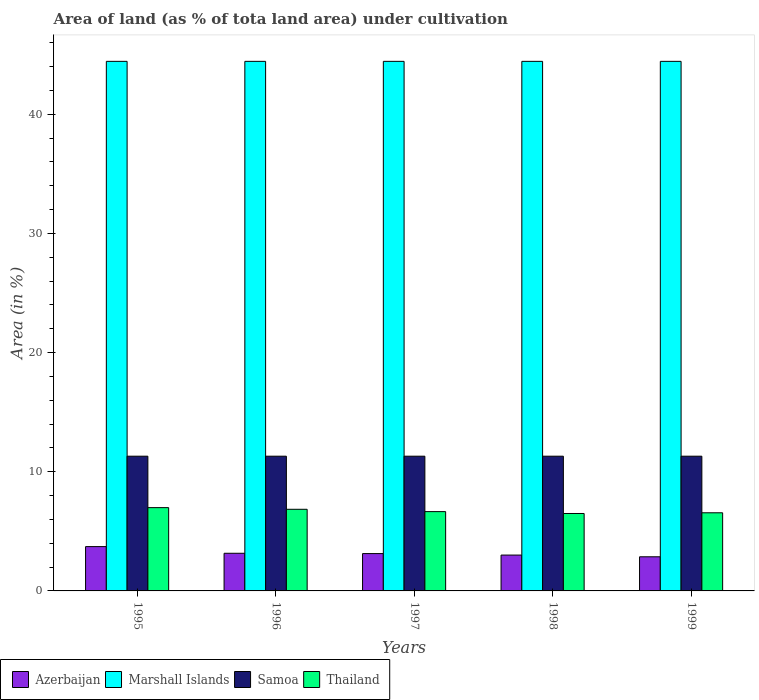How many different coloured bars are there?
Offer a terse response. 4. How many groups of bars are there?
Your answer should be very brief. 5. Are the number of bars on each tick of the X-axis equal?
Provide a succinct answer. Yes. How many bars are there on the 3rd tick from the left?
Your response must be concise. 4. What is the label of the 3rd group of bars from the left?
Your response must be concise. 1997. What is the percentage of land under cultivation in Azerbaijan in 1998?
Give a very brief answer. 3.01. Across all years, what is the maximum percentage of land under cultivation in Thailand?
Offer a very short reply. 6.99. Across all years, what is the minimum percentage of land under cultivation in Thailand?
Your response must be concise. 6.5. In which year was the percentage of land under cultivation in Thailand maximum?
Give a very brief answer. 1995. In which year was the percentage of land under cultivation in Azerbaijan minimum?
Keep it short and to the point. 1999. What is the total percentage of land under cultivation in Azerbaijan in the graph?
Your answer should be compact. 15.89. What is the difference between the percentage of land under cultivation in Thailand in 1996 and that in 1997?
Provide a short and direct response. 0.2. What is the difference between the percentage of land under cultivation in Marshall Islands in 1999 and the percentage of land under cultivation in Azerbaijan in 1995?
Offer a very short reply. 40.73. What is the average percentage of land under cultivation in Samoa per year?
Ensure brevity in your answer.  11.31. In the year 1995, what is the difference between the percentage of land under cultivation in Thailand and percentage of land under cultivation in Azerbaijan?
Your response must be concise. 3.27. In how many years, is the percentage of land under cultivation in Thailand greater than 40 %?
Provide a short and direct response. 0. Is the difference between the percentage of land under cultivation in Thailand in 1995 and 1996 greater than the difference between the percentage of land under cultivation in Azerbaijan in 1995 and 1996?
Your answer should be compact. No. In how many years, is the percentage of land under cultivation in Thailand greater than the average percentage of land under cultivation in Thailand taken over all years?
Your answer should be very brief. 2. What does the 1st bar from the left in 1996 represents?
Ensure brevity in your answer.  Azerbaijan. What does the 3rd bar from the right in 1995 represents?
Ensure brevity in your answer.  Marshall Islands. How many bars are there?
Make the answer very short. 20. How many years are there in the graph?
Provide a short and direct response. 5. What is the difference between two consecutive major ticks on the Y-axis?
Your response must be concise. 10. Does the graph contain grids?
Ensure brevity in your answer.  No. How are the legend labels stacked?
Your answer should be very brief. Horizontal. What is the title of the graph?
Give a very brief answer. Area of land (as % of tota land area) under cultivation. Does "Iran" appear as one of the legend labels in the graph?
Your answer should be very brief. No. What is the label or title of the Y-axis?
Make the answer very short. Area (in %). What is the Area (in %) of Azerbaijan in 1995?
Make the answer very short. 3.72. What is the Area (in %) in Marshall Islands in 1995?
Offer a very short reply. 44.44. What is the Area (in %) in Samoa in 1995?
Your response must be concise. 11.31. What is the Area (in %) in Thailand in 1995?
Give a very brief answer. 6.99. What is the Area (in %) in Azerbaijan in 1996?
Your answer should be very brief. 3.16. What is the Area (in %) of Marshall Islands in 1996?
Provide a short and direct response. 44.44. What is the Area (in %) of Samoa in 1996?
Offer a terse response. 11.31. What is the Area (in %) in Thailand in 1996?
Your answer should be compact. 6.85. What is the Area (in %) of Azerbaijan in 1997?
Provide a succinct answer. 3.13. What is the Area (in %) in Marshall Islands in 1997?
Make the answer very short. 44.44. What is the Area (in %) in Samoa in 1997?
Your response must be concise. 11.31. What is the Area (in %) of Thailand in 1997?
Give a very brief answer. 6.66. What is the Area (in %) in Azerbaijan in 1998?
Offer a terse response. 3.01. What is the Area (in %) in Marshall Islands in 1998?
Provide a succinct answer. 44.44. What is the Area (in %) of Samoa in 1998?
Make the answer very short. 11.31. What is the Area (in %) in Thailand in 1998?
Offer a very short reply. 6.5. What is the Area (in %) of Azerbaijan in 1999?
Ensure brevity in your answer.  2.86. What is the Area (in %) in Marshall Islands in 1999?
Your answer should be very brief. 44.44. What is the Area (in %) in Samoa in 1999?
Ensure brevity in your answer.  11.31. What is the Area (in %) in Thailand in 1999?
Make the answer very short. 6.56. Across all years, what is the maximum Area (in %) in Azerbaijan?
Give a very brief answer. 3.72. Across all years, what is the maximum Area (in %) in Marshall Islands?
Provide a short and direct response. 44.44. Across all years, what is the maximum Area (in %) of Samoa?
Provide a short and direct response. 11.31. Across all years, what is the maximum Area (in %) of Thailand?
Your response must be concise. 6.99. Across all years, what is the minimum Area (in %) of Azerbaijan?
Provide a succinct answer. 2.86. Across all years, what is the minimum Area (in %) in Marshall Islands?
Provide a short and direct response. 44.44. Across all years, what is the minimum Area (in %) of Samoa?
Offer a very short reply. 11.31. Across all years, what is the minimum Area (in %) of Thailand?
Offer a very short reply. 6.5. What is the total Area (in %) of Azerbaijan in the graph?
Offer a very short reply. 15.89. What is the total Area (in %) of Marshall Islands in the graph?
Keep it short and to the point. 222.22. What is the total Area (in %) in Samoa in the graph?
Provide a succinct answer. 56.54. What is the total Area (in %) in Thailand in the graph?
Provide a succinct answer. 33.55. What is the difference between the Area (in %) in Azerbaijan in 1995 and that in 1996?
Provide a succinct answer. 0.56. What is the difference between the Area (in %) of Marshall Islands in 1995 and that in 1996?
Offer a very short reply. 0. What is the difference between the Area (in %) in Thailand in 1995 and that in 1996?
Your response must be concise. 0.14. What is the difference between the Area (in %) of Azerbaijan in 1995 and that in 1997?
Give a very brief answer. 0.59. What is the difference between the Area (in %) of Marshall Islands in 1995 and that in 1997?
Your response must be concise. 0. What is the difference between the Area (in %) in Thailand in 1995 and that in 1997?
Make the answer very short. 0.33. What is the difference between the Area (in %) in Azerbaijan in 1995 and that in 1998?
Offer a very short reply. 0.71. What is the difference between the Area (in %) of Marshall Islands in 1995 and that in 1998?
Your answer should be compact. 0. What is the difference between the Area (in %) in Samoa in 1995 and that in 1998?
Give a very brief answer. 0. What is the difference between the Area (in %) in Thailand in 1995 and that in 1998?
Your answer should be compact. 0.49. What is the difference between the Area (in %) of Azerbaijan in 1995 and that in 1999?
Offer a very short reply. 0.85. What is the difference between the Area (in %) in Marshall Islands in 1995 and that in 1999?
Your answer should be compact. 0. What is the difference between the Area (in %) in Samoa in 1995 and that in 1999?
Give a very brief answer. 0. What is the difference between the Area (in %) in Thailand in 1995 and that in 1999?
Keep it short and to the point. 0.43. What is the difference between the Area (in %) of Azerbaijan in 1996 and that in 1997?
Keep it short and to the point. 0.03. What is the difference between the Area (in %) in Samoa in 1996 and that in 1997?
Give a very brief answer. 0. What is the difference between the Area (in %) in Thailand in 1996 and that in 1997?
Make the answer very short. 0.2. What is the difference between the Area (in %) of Azerbaijan in 1996 and that in 1998?
Offer a very short reply. 0.15. What is the difference between the Area (in %) of Marshall Islands in 1996 and that in 1998?
Offer a terse response. 0. What is the difference between the Area (in %) in Thailand in 1996 and that in 1998?
Offer a terse response. 0.35. What is the difference between the Area (in %) in Azerbaijan in 1996 and that in 1999?
Provide a succinct answer. 0.29. What is the difference between the Area (in %) of Marshall Islands in 1996 and that in 1999?
Provide a short and direct response. 0. What is the difference between the Area (in %) of Thailand in 1996 and that in 1999?
Your response must be concise. 0.29. What is the difference between the Area (in %) in Azerbaijan in 1997 and that in 1998?
Keep it short and to the point. 0.13. What is the difference between the Area (in %) in Thailand in 1997 and that in 1998?
Make the answer very short. 0.16. What is the difference between the Area (in %) of Azerbaijan in 1997 and that in 1999?
Your answer should be very brief. 0.27. What is the difference between the Area (in %) of Samoa in 1997 and that in 1999?
Give a very brief answer. 0. What is the difference between the Area (in %) in Thailand in 1997 and that in 1999?
Provide a succinct answer. 0.1. What is the difference between the Area (in %) of Azerbaijan in 1998 and that in 1999?
Offer a terse response. 0.14. What is the difference between the Area (in %) in Thailand in 1998 and that in 1999?
Ensure brevity in your answer.  -0.06. What is the difference between the Area (in %) in Azerbaijan in 1995 and the Area (in %) in Marshall Islands in 1996?
Provide a succinct answer. -40.73. What is the difference between the Area (in %) of Azerbaijan in 1995 and the Area (in %) of Samoa in 1996?
Provide a succinct answer. -7.59. What is the difference between the Area (in %) of Azerbaijan in 1995 and the Area (in %) of Thailand in 1996?
Offer a terse response. -3.13. What is the difference between the Area (in %) in Marshall Islands in 1995 and the Area (in %) in Samoa in 1996?
Ensure brevity in your answer.  33.14. What is the difference between the Area (in %) in Marshall Islands in 1995 and the Area (in %) in Thailand in 1996?
Your answer should be compact. 37.59. What is the difference between the Area (in %) of Samoa in 1995 and the Area (in %) of Thailand in 1996?
Your answer should be very brief. 4.46. What is the difference between the Area (in %) in Azerbaijan in 1995 and the Area (in %) in Marshall Islands in 1997?
Your answer should be very brief. -40.73. What is the difference between the Area (in %) in Azerbaijan in 1995 and the Area (in %) in Samoa in 1997?
Make the answer very short. -7.59. What is the difference between the Area (in %) of Azerbaijan in 1995 and the Area (in %) of Thailand in 1997?
Provide a short and direct response. -2.94. What is the difference between the Area (in %) of Marshall Islands in 1995 and the Area (in %) of Samoa in 1997?
Offer a terse response. 33.14. What is the difference between the Area (in %) in Marshall Islands in 1995 and the Area (in %) in Thailand in 1997?
Ensure brevity in your answer.  37.79. What is the difference between the Area (in %) in Samoa in 1995 and the Area (in %) in Thailand in 1997?
Your answer should be compact. 4.65. What is the difference between the Area (in %) of Azerbaijan in 1995 and the Area (in %) of Marshall Islands in 1998?
Provide a succinct answer. -40.73. What is the difference between the Area (in %) of Azerbaijan in 1995 and the Area (in %) of Samoa in 1998?
Provide a short and direct response. -7.59. What is the difference between the Area (in %) of Azerbaijan in 1995 and the Area (in %) of Thailand in 1998?
Offer a very short reply. -2.78. What is the difference between the Area (in %) in Marshall Islands in 1995 and the Area (in %) in Samoa in 1998?
Ensure brevity in your answer.  33.14. What is the difference between the Area (in %) in Marshall Islands in 1995 and the Area (in %) in Thailand in 1998?
Offer a very short reply. 37.95. What is the difference between the Area (in %) in Samoa in 1995 and the Area (in %) in Thailand in 1998?
Keep it short and to the point. 4.81. What is the difference between the Area (in %) in Azerbaijan in 1995 and the Area (in %) in Marshall Islands in 1999?
Make the answer very short. -40.73. What is the difference between the Area (in %) of Azerbaijan in 1995 and the Area (in %) of Samoa in 1999?
Your answer should be compact. -7.59. What is the difference between the Area (in %) of Azerbaijan in 1995 and the Area (in %) of Thailand in 1999?
Your answer should be compact. -2.84. What is the difference between the Area (in %) in Marshall Islands in 1995 and the Area (in %) in Samoa in 1999?
Make the answer very short. 33.14. What is the difference between the Area (in %) of Marshall Islands in 1995 and the Area (in %) of Thailand in 1999?
Your response must be concise. 37.89. What is the difference between the Area (in %) of Samoa in 1995 and the Area (in %) of Thailand in 1999?
Offer a very short reply. 4.75. What is the difference between the Area (in %) in Azerbaijan in 1996 and the Area (in %) in Marshall Islands in 1997?
Provide a succinct answer. -41.29. What is the difference between the Area (in %) in Azerbaijan in 1996 and the Area (in %) in Samoa in 1997?
Offer a very short reply. -8.15. What is the difference between the Area (in %) of Azerbaijan in 1996 and the Area (in %) of Thailand in 1997?
Keep it short and to the point. -3.5. What is the difference between the Area (in %) in Marshall Islands in 1996 and the Area (in %) in Samoa in 1997?
Provide a short and direct response. 33.14. What is the difference between the Area (in %) of Marshall Islands in 1996 and the Area (in %) of Thailand in 1997?
Your answer should be very brief. 37.79. What is the difference between the Area (in %) of Samoa in 1996 and the Area (in %) of Thailand in 1997?
Keep it short and to the point. 4.65. What is the difference between the Area (in %) of Azerbaijan in 1996 and the Area (in %) of Marshall Islands in 1998?
Your response must be concise. -41.29. What is the difference between the Area (in %) in Azerbaijan in 1996 and the Area (in %) in Samoa in 1998?
Ensure brevity in your answer.  -8.15. What is the difference between the Area (in %) in Azerbaijan in 1996 and the Area (in %) in Thailand in 1998?
Make the answer very short. -3.34. What is the difference between the Area (in %) of Marshall Islands in 1996 and the Area (in %) of Samoa in 1998?
Ensure brevity in your answer.  33.14. What is the difference between the Area (in %) of Marshall Islands in 1996 and the Area (in %) of Thailand in 1998?
Give a very brief answer. 37.95. What is the difference between the Area (in %) in Samoa in 1996 and the Area (in %) in Thailand in 1998?
Provide a short and direct response. 4.81. What is the difference between the Area (in %) in Azerbaijan in 1996 and the Area (in %) in Marshall Islands in 1999?
Your answer should be compact. -41.29. What is the difference between the Area (in %) in Azerbaijan in 1996 and the Area (in %) in Samoa in 1999?
Ensure brevity in your answer.  -8.15. What is the difference between the Area (in %) in Azerbaijan in 1996 and the Area (in %) in Thailand in 1999?
Offer a very short reply. -3.4. What is the difference between the Area (in %) in Marshall Islands in 1996 and the Area (in %) in Samoa in 1999?
Give a very brief answer. 33.14. What is the difference between the Area (in %) in Marshall Islands in 1996 and the Area (in %) in Thailand in 1999?
Your answer should be very brief. 37.89. What is the difference between the Area (in %) in Samoa in 1996 and the Area (in %) in Thailand in 1999?
Make the answer very short. 4.75. What is the difference between the Area (in %) in Azerbaijan in 1997 and the Area (in %) in Marshall Islands in 1998?
Provide a short and direct response. -41.31. What is the difference between the Area (in %) of Azerbaijan in 1997 and the Area (in %) of Samoa in 1998?
Your response must be concise. -8.17. What is the difference between the Area (in %) of Azerbaijan in 1997 and the Area (in %) of Thailand in 1998?
Provide a short and direct response. -3.36. What is the difference between the Area (in %) in Marshall Islands in 1997 and the Area (in %) in Samoa in 1998?
Your answer should be compact. 33.14. What is the difference between the Area (in %) of Marshall Islands in 1997 and the Area (in %) of Thailand in 1998?
Your answer should be very brief. 37.95. What is the difference between the Area (in %) in Samoa in 1997 and the Area (in %) in Thailand in 1998?
Give a very brief answer. 4.81. What is the difference between the Area (in %) of Azerbaijan in 1997 and the Area (in %) of Marshall Islands in 1999?
Offer a very short reply. -41.31. What is the difference between the Area (in %) of Azerbaijan in 1997 and the Area (in %) of Samoa in 1999?
Your answer should be compact. -8.17. What is the difference between the Area (in %) in Azerbaijan in 1997 and the Area (in %) in Thailand in 1999?
Your answer should be compact. -3.42. What is the difference between the Area (in %) of Marshall Islands in 1997 and the Area (in %) of Samoa in 1999?
Give a very brief answer. 33.14. What is the difference between the Area (in %) of Marshall Islands in 1997 and the Area (in %) of Thailand in 1999?
Your answer should be compact. 37.89. What is the difference between the Area (in %) in Samoa in 1997 and the Area (in %) in Thailand in 1999?
Provide a short and direct response. 4.75. What is the difference between the Area (in %) of Azerbaijan in 1998 and the Area (in %) of Marshall Islands in 1999?
Offer a terse response. -41.44. What is the difference between the Area (in %) in Azerbaijan in 1998 and the Area (in %) in Samoa in 1999?
Make the answer very short. -8.3. What is the difference between the Area (in %) of Azerbaijan in 1998 and the Area (in %) of Thailand in 1999?
Offer a terse response. -3.55. What is the difference between the Area (in %) in Marshall Islands in 1998 and the Area (in %) in Samoa in 1999?
Make the answer very short. 33.14. What is the difference between the Area (in %) in Marshall Islands in 1998 and the Area (in %) in Thailand in 1999?
Offer a terse response. 37.89. What is the difference between the Area (in %) in Samoa in 1998 and the Area (in %) in Thailand in 1999?
Offer a terse response. 4.75. What is the average Area (in %) of Azerbaijan per year?
Offer a very short reply. 3.18. What is the average Area (in %) of Marshall Islands per year?
Keep it short and to the point. 44.44. What is the average Area (in %) of Samoa per year?
Offer a terse response. 11.31. What is the average Area (in %) in Thailand per year?
Provide a short and direct response. 6.71. In the year 1995, what is the difference between the Area (in %) in Azerbaijan and Area (in %) in Marshall Islands?
Provide a succinct answer. -40.73. In the year 1995, what is the difference between the Area (in %) in Azerbaijan and Area (in %) in Samoa?
Your answer should be compact. -7.59. In the year 1995, what is the difference between the Area (in %) in Azerbaijan and Area (in %) in Thailand?
Your answer should be very brief. -3.27. In the year 1995, what is the difference between the Area (in %) of Marshall Islands and Area (in %) of Samoa?
Ensure brevity in your answer.  33.14. In the year 1995, what is the difference between the Area (in %) of Marshall Islands and Area (in %) of Thailand?
Your answer should be very brief. 37.45. In the year 1995, what is the difference between the Area (in %) of Samoa and Area (in %) of Thailand?
Keep it short and to the point. 4.32. In the year 1996, what is the difference between the Area (in %) in Azerbaijan and Area (in %) in Marshall Islands?
Your answer should be very brief. -41.29. In the year 1996, what is the difference between the Area (in %) of Azerbaijan and Area (in %) of Samoa?
Ensure brevity in your answer.  -8.15. In the year 1996, what is the difference between the Area (in %) of Azerbaijan and Area (in %) of Thailand?
Keep it short and to the point. -3.69. In the year 1996, what is the difference between the Area (in %) in Marshall Islands and Area (in %) in Samoa?
Offer a very short reply. 33.14. In the year 1996, what is the difference between the Area (in %) of Marshall Islands and Area (in %) of Thailand?
Your response must be concise. 37.59. In the year 1996, what is the difference between the Area (in %) in Samoa and Area (in %) in Thailand?
Offer a very short reply. 4.46. In the year 1997, what is the difference between the Area (in %) in Azerbaijan and Area (in %) in Marshall Islands?
Provide a short and direct response. -41.31. In the year 1997, what is the difference between the Area (in %) of Azerbaijan and Area (in %) of Samoa?
Provide a succinct answer. -8.17. In the year 1997, what is the difference between the Area (in %) in Azerbaijan and Area (in %) in Thailand?
Make the answer very short. -3.52. In the year 1997, what is the difference between the Area (in %) of Marshall Islands and Area (in %) of Samoa?
Your response must be concise. 33.14. In the year 1997, what is the difference between the Area (in %) of Marshall Islands and Area (in %) of Thailand?
Provide a succinct answer. 37.79. In the year 1997, what is the difference between the Area (in %) of Samoa and Area (in %) of Thailand?
Provide a short and direct response. 4.65. In the year 1998, what is the difference between the Area (in %) in Azerbaijan and Area (in %) in Marshall Islands?
Ensure brevity in your answer.  -41.44. In the year 1998, what is the difference between the Area (in %) of Azerbaijan and Area (in %) of Samoa?
Give a very brief answer. -8.3. In the year 1998, what is the difference between the Area (in %) of Azerbaijan and Area (in %) of Thailand?
Provide a short and direct response. -3.49. In the year 1998, what is the difference between the Area (in %) in Marshall Islands and Area (in %) in Samoa?
Ensure brevity in your answer.  33.14. In the year 1998, what is the difference between the Area (in %) of Marshall Islands and Area (in %) of Thailand?
Your response must be concise. 37.95. In the year 1998, what is the difference between the Area (in %) of Samoa and Area (in %) of Thailand?
Provide a succinct answer. 4.81. In the year 1999, what is the difference between the Area (in %) of Azerbaijan and Area (in %) of Marshall Islands?
Your response must be concise. -41.58. In the year 1999, what is the difference between the Area (in %) of Azerbaijan and Area (in %) of Samoa?
Offer a terse response. -8.44. In the year 1999, what is the difference between the Area (in %) in Azerbaijan and Area (in %) in Thailand?
Your answer should be very brief. -3.69. In the year 1999, what is the difference between the Area (in %) of Marshall Islands and Area (in %) of Samoa?
Your answer should be compact. 33.14. In the year 1999, what is the difference between the Area (in %) of Marshall Islands and Area (in %) of Thailand?
Provide a succinct answer. 37.89. In the year 1999, what is the difference between the Area (in %) in Samoa and Area (in %) in Thailand?
Keep it short and to the point. 4.75. What is the ratio of the Area (in %) in Azerbaijan in 1995 to that in 1996?
Your answer should be very brief. 1.18. What is the ratio of the Area (in %) in Thailand in 1995 to that in 1996?
Offer a terse response. 1.02. What is the ratio of the Area (in %) of Azerbaijan in 1995 to that in 1997?
Provide a succinct answer. 1.19. What is the ratio of the Area (in %) in Thailand in 1995 to that in 1997?
Offer a very short reply. 1.05. What is the ratio of the Area (in %) in Azerbaijan in 1995 to that in 1998?
Provide a short and direct response. 1.24. What is the ratio of the Area (in %) of Samoa in 1995 to that in 1998?
Provide a succinct answer. 1. What is the ratio of the Area (in %) of Thailand in 1995 to that in 1998?
Provide a succinct answer. 1.08. What is the ratio of the Area (in %) in Azerbaijan in 1995 to that in 1999?
Offer a terse response. 1.3. What is the ratio of the Area (in %) of Thailand in 1995 to that in 1999?
Keep it short and to the point. 1.07. What is the ratio of the Area (in %) of Marshall Islands in 1996 to that in 1997?
Offer a very short reply. 1. What is the ratio of the Area (in %) of Samoa in 1996 to that in 1997?
Your answer should be compact. 1. What is the ratio of the Area (in %) of Thailand in 1996 to that in 1997?
Your answer should be very brief. 1.03. What is the ratio of the Area (in %) of Marshall Islands in 1996 to that in 1998?
Give a very brief answer. 1. What is the ratio of the Area (in %) in Thailand in 1996 to that in 1998?
Keep it short and to the point. 1.05. What is the ratio of the Area (in %) of Azerbaijan in 1996 to that in 1999?
Give a very brief answer. 1.1. What is the ratio of the Area (in %) of Thailand in 1996 to that in 1999?
Your answer should be very brief. 1.04. What is the ratio of the Area (in %) in Azerbaijan in 1997 to that in 1998?
Provide a succinct answer. 1.04. What is the ratio of the Area (in %) in Thailand in 1997 to that in 1998?
Your response must be concise. 1.02. What is the ratio of the Area (in %) in Azerbaijan in 1997 to that in 1999?
Make the answer very short. 1.09. What is the ratio of the Area (in %) in Samoa in 1997 to that in 1999?
Keep it short and to the point. 1. What is the ratio of the Area (in %) of Thailand in 1997 to that in 1999?
Provide a succinct answer. 1.01. What is the ratio of the Area (in %) in Azerbaijan in 1998 to that in 1999?
Make the answer very short. 1.05. What is the ratio of the Area (in %) of Thailand in 1998 to that in 1999?
Offer a very short reply. 0.99. What is the difference between the highest and the second highest Area (in %) of Azerbaijan?
Your answer should be very brief. 0.56. What is the difference between the highest and the second highest Area (in %) in Samoa?
Provide a short and direct response. 0. What is the difference between the highest and the second highest Area (in %) in Thailand?
Your response must be concise. 0.14. What is the difference between the highest and the lowest Area (in %) of Azerbaijan?
Provide a succinct answer. 0.85. What is the difference between the highest and the lowest Area (in %) of Marshall Islands?
Provide a succinct answer. 0. What is the difference between the highest and the lowest Area (in %) of Samoa?
Provide a succinct answer. 0. What is the difference between the highest and the lowest Area (in %) in Thailand?
Give a very brief answer. 0.49. 